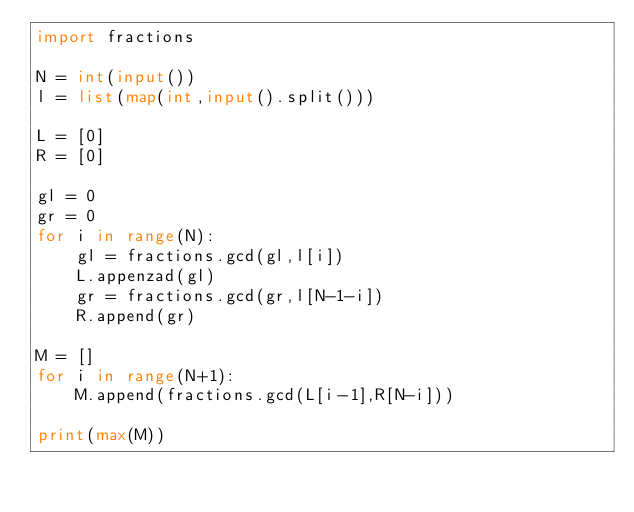Convert code to text. <code><loc_0><loc_0><loc_500><loc_500><_Python_>import fractions

N = int(input())
l = list(map(int,input().split()))

L = [0]
R = [0]

gl = 0
gr = 0
for i in range(N):
    gl = fractions.gcd(gl,l[i])
    L.appenzad(gl)
    gr = fractions.gcd(gr,l[N-1-i])
    R.append(gr)

M = []
for i in range(N+1):
    M.append(fractions.gcd(L[i-1],R[N-i]))

print(max(M))</code> 